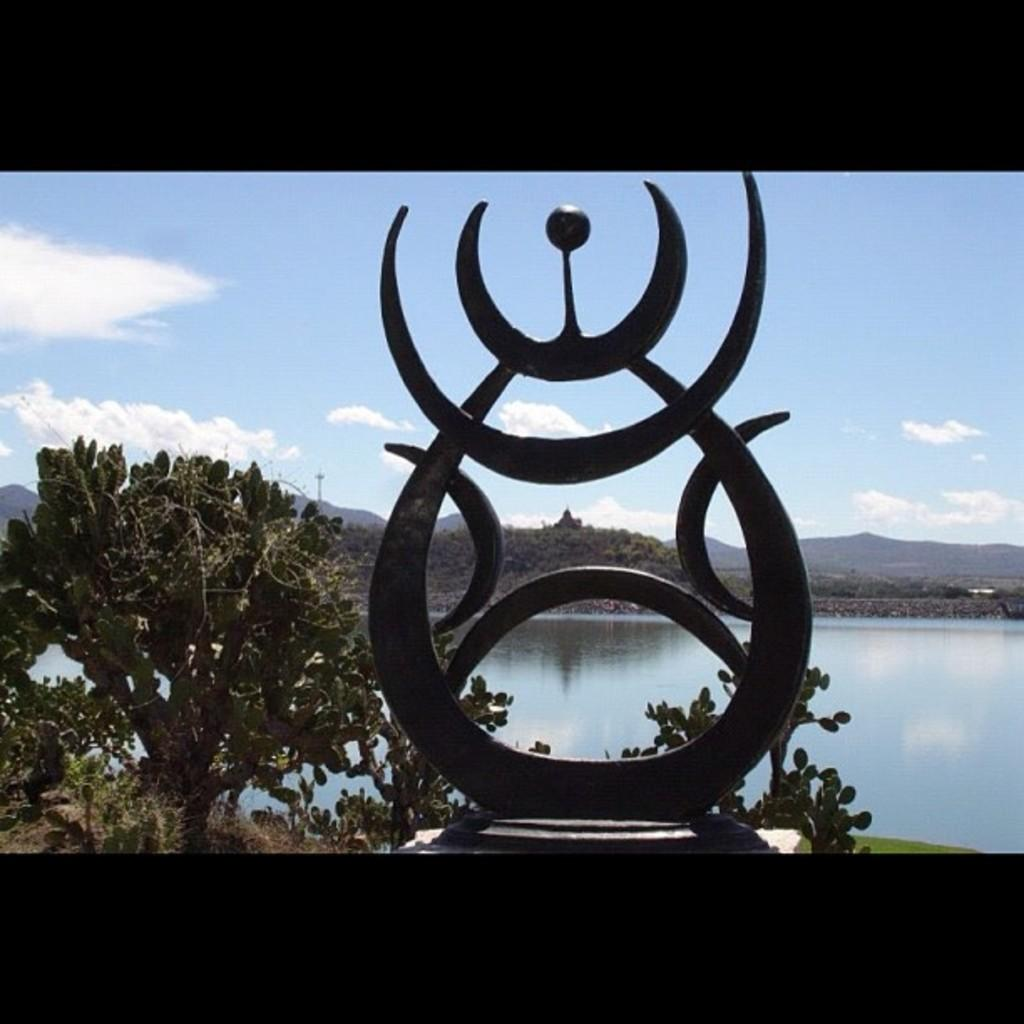What is the main subject in the image? There is a statue in the image. What type of natural elements can be seen in the image? There are trees and water visible in the image. What can be seen in the background of the image? There is a mountain and the sky visible in the background of the image. What is the condition of the sky in the image? Clouds are present in the sky. What type of sweater is the statue wearing in the image? The statue is not wearing a sweater, as it is a non-living object and does not require clothing. What type of breakfast is being served in the image? There is no breakfast or any food visible in the image. 